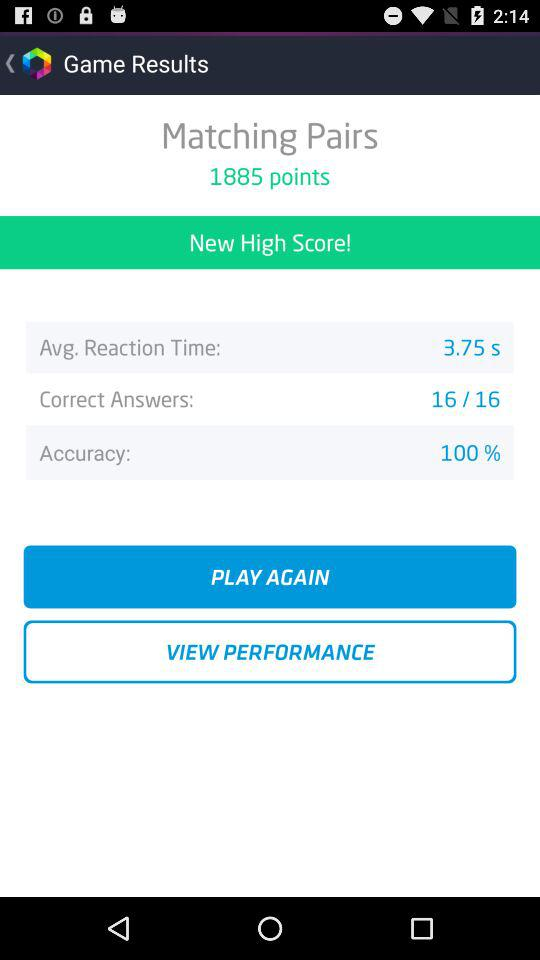How many points is the player's current high score?
Answer the question using a single word or phrase. 1885 